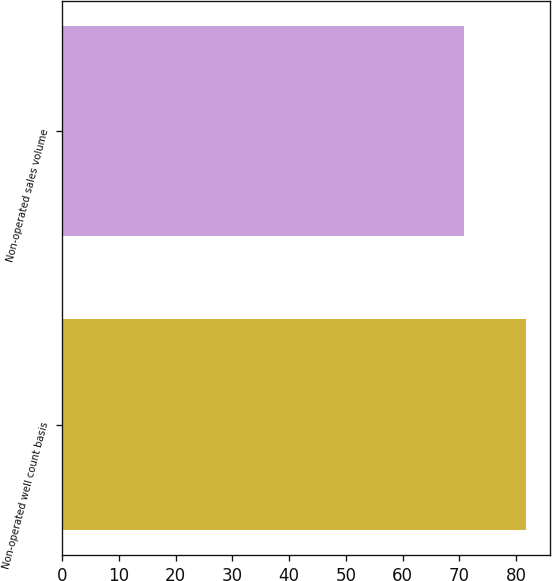Convert chart to OTSL. <chart><loc_0><loc_0><loc_500><loc_500><bar_chart><fcel>Non-operated well count basis<fcel>Non-operated sales volume<nl><fcel>81.8<fcel>70.9<nl></chart> 